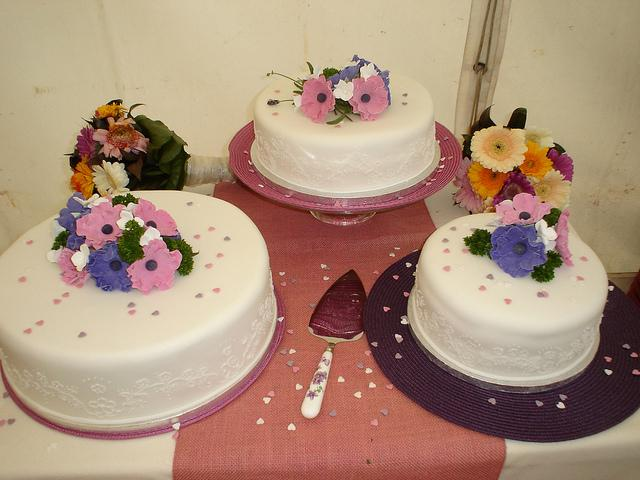What time of icing is on all of the cakes?

Choices:
A) vanilla
B) strawberry
C) mint
D) chocolate vanilla 